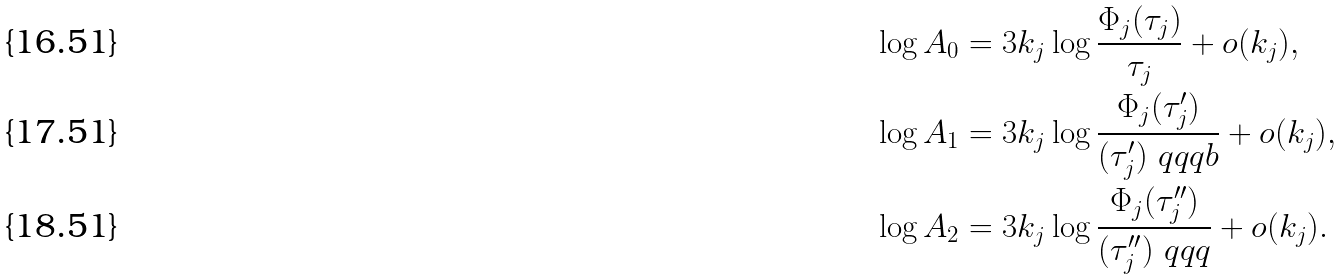Convert formula to latex. <formula><loc_0><loc_0><loc_500><loc_500>\log A _ { 0 } & = 3 k _ { j } \log \frac { \Phi _ { j } ( \tau _ { j } ) } { \tau _ { j } } + o ( k _ { j } ) , \\ \log A _ { 1 } & = 3 k _ { j } \log \frac { \Phi _ { j } ( \tau _ { j } ^ { \prime } ) } { ( \tau _ { j } ^ { \prime } ) \ q q q b } + o ( k _ { j } ) , \\ \log A _ { 2 } & = 3 k _ { j } \log \frac { \Phi _ { j } ( \tau _ { j } ^ { \prime \prime } ) } { ( \tau ^ { \prime \prime } _ { j } ) \ q q q } + o ( k _ { j } ) .</formula> 